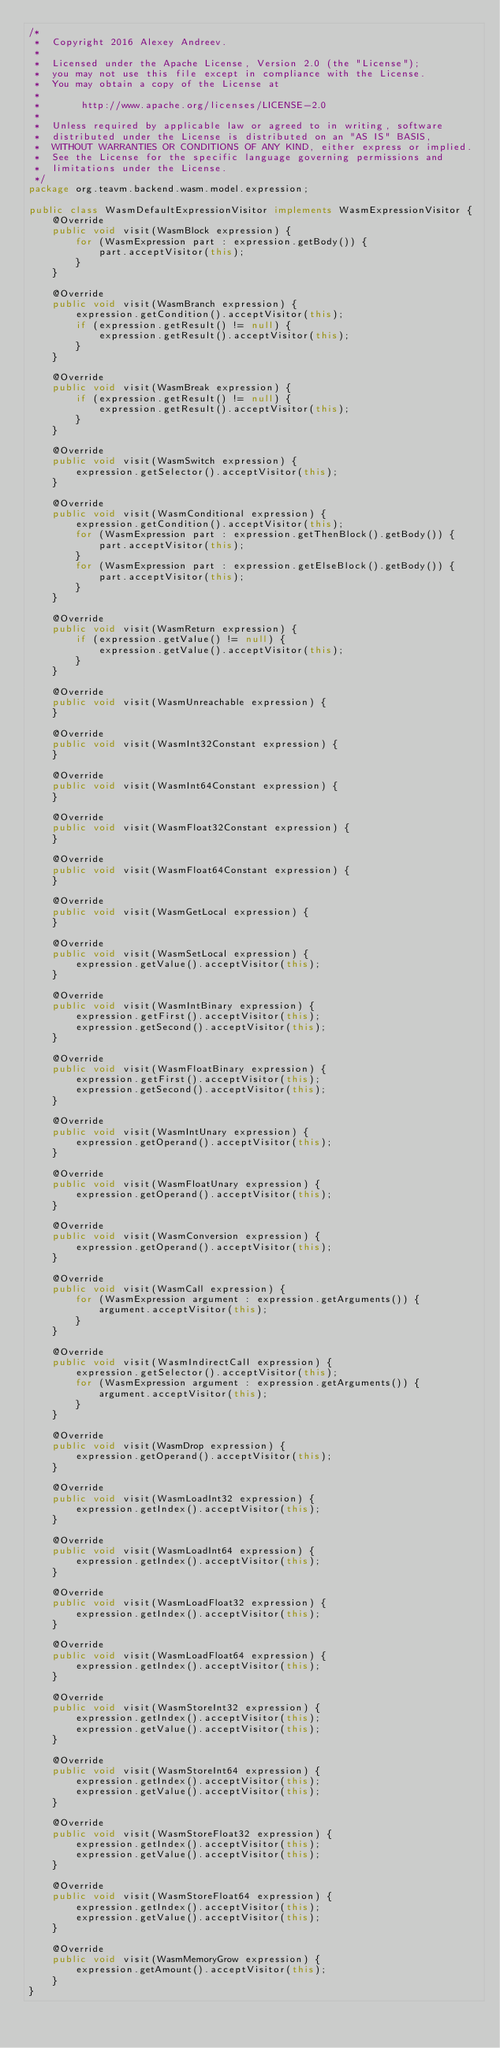Convert code to text. <code><loc_0><loc_0><loc_500><loc_500><_Java_>/*
 *  Copyright 2016 Alexey Andreev.
 *
 *  Licensed under the Apache License, Version 2.0 (the "License");
 *  you may not use this file except in compliance with the License.
 *  You may obtain a copy of the License at
 *
 *       http://www.apache.org/licenses/LICENSE-2.0
 *
 *  Unless required by applicable law or agreed to in writing, software
 *  distributed under the License is distributed on an "AS IS" BASIS,
 *  WITHOUT WARRANTIES OR CONDITIONS OF ANY KIND, either express or implied.
 *  See the License for the specific language governing permissions and
 *  limitations under the License.
 */
package org.teavm.backend.wasm.model.expression;

public class WasmDefaultExpressionVisitor implements WasmExpressionVisitor {
    @Override
    public void visit(WasmBlock expression) {
        for (WasmExpression part : expression.getBody()) {
            part.acceptVisitor(this);
        }
    }

    @Override
    public void visit(WasmBranch expression) {
        expression.getCondition().acceptVisitor(this);
        if (expression.getResult() != null) {
            expression.getResult().acceptVisitor(this);
        }
    }

    @Override
    public void visit(WasmBreak expression) {
        if (expression.getResult() != null) {
            expression.getResult().acceptVisitor(this);
        }
    }

    @Override
    public void visit(WasmSwitch expression) {
        expression.getSelector().acceptVisitor(this);
    }

    @Override
    public void visit(WasmConditional expression) {
        expression.getCondition().acceptVisitor(this);
        for (WasmExpression part : expression.getThenBlock().getBody()) {
            part.acceptVisitor(this);
        }
        for (WasmExpression part : expression.getElseBlock().getBody()) {
            part.acceptVisitor(this);
        }
    }

    @Override
    public void visit(WasmReturn expression) {
        if (expression.getValue() != null) {
            expression.getValue().acceptVisitor(this);
        }
    }

    @Override
    public void visit(WasmUnreachable expression) {
    }

    @Override
    public void visit(WasmInt32Constant expression) {
    }

    @Override
    public void visit(WasmInt64Constant expression) {
    }

    @Override
    public void visit(WasmFloat32Constant expression) {
    }

    @Override
    public void visit(WasmFloat64Constant expression) {
    }

    @Override
    public void visit(WasmGetLocal expression) {
    }

    @Override
    public void visit(WasmSetLocal expression) {
        expression.getValue().acceptVisitor(this);
    }

    @Override
    public void visit(WasmIntBinary expression) {
        expression.getFirst().acceptVisitor(this);
        expression.getSecond().acceptVisitor(this);
    }

    @Override
    public void visit(WasmFloatBinary expression) {
        expression.getFirst().acceptVisitor(this);
        expression.getSecond().acceptVisitor(this);
    }

    @Override
    public void visit(WasmIntUnary expression) {
        expression.getOperand().acceptVisitor(this);
    }

    @Override
    public void visit(WasmFloatUnary expression) {
        expression.getOperand().acceptVisitor(this);
    }

    @Override
    public void visit(WasmConversion expression) {
        expression.getOperand().acceptVisitor(this);
    }

    @Override
    public void visit(WasmCall expression) {
        for (WasmExpression argument : expression.getArguments()) {
            argument.acceptVisitor(this);
        }
    }

    @Override
    public void visit(WasmIndirectCall expression) {
        expression.getSelector().acceptVisitor(this);
        for (WasmExpression argument : expression.getArguments()) {
            argument.acceptVisitor(this);
        }
    }

    @Override
    public void visit(WasmDrop expression) {
        expression.getOperand().acceptVisitor(this);
    }

    @Override
    public void visit(WasmLoadInt32 expression) {
        expression.getIndex().acceptVisitor(this);
    }

    @Override
    public void visit(WasmLoadInt64 expression) {
        expression.getIndex().acceptVisitor(this);
    }

    @Override
    public void visit(WasmLoadFloat32 expression) {
        expression.getIndex().acceptVisitor(this);
    }

    @Override
    public void visit(WasmLoadFloat64 expression) {
        expression.getIndex().acceptVisitor(this);
    }

    @Override
    public void visit(WasmStoreInt32 expression) {
        expression.getIndex().acceptVisitor(this);
        expression.getValue().acceptVisitor(this);
    }

    @Override
    public void visit(WasmStoreInt64 expression) {
        expression.getIndex().acceptVisitor(this);
        expression.getValue().acceptVisitor(this);
    }

    @Override
    public void visit(WasmStoreFloat32 expression) {
        expression.getIndex().acceptVisitor(this);
        expression.getValue().acceptVisitor(this);
    }

    @Override
    public void visit(WasmStoreFloat64 expression) {
        expression.getIndex().acceptVisitor(this);
        expression.getValue().acceptVisitor(this);
    }

    @Override
    public void visit(WasmMemoryGrow expression) {
        expression.getAmount().acceptVisitor(this);
    }
}
</code> 